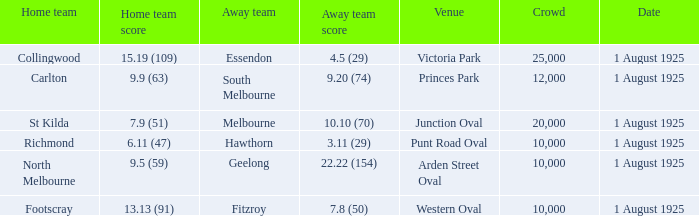Which team plays home at Princes Park? Carlton. 